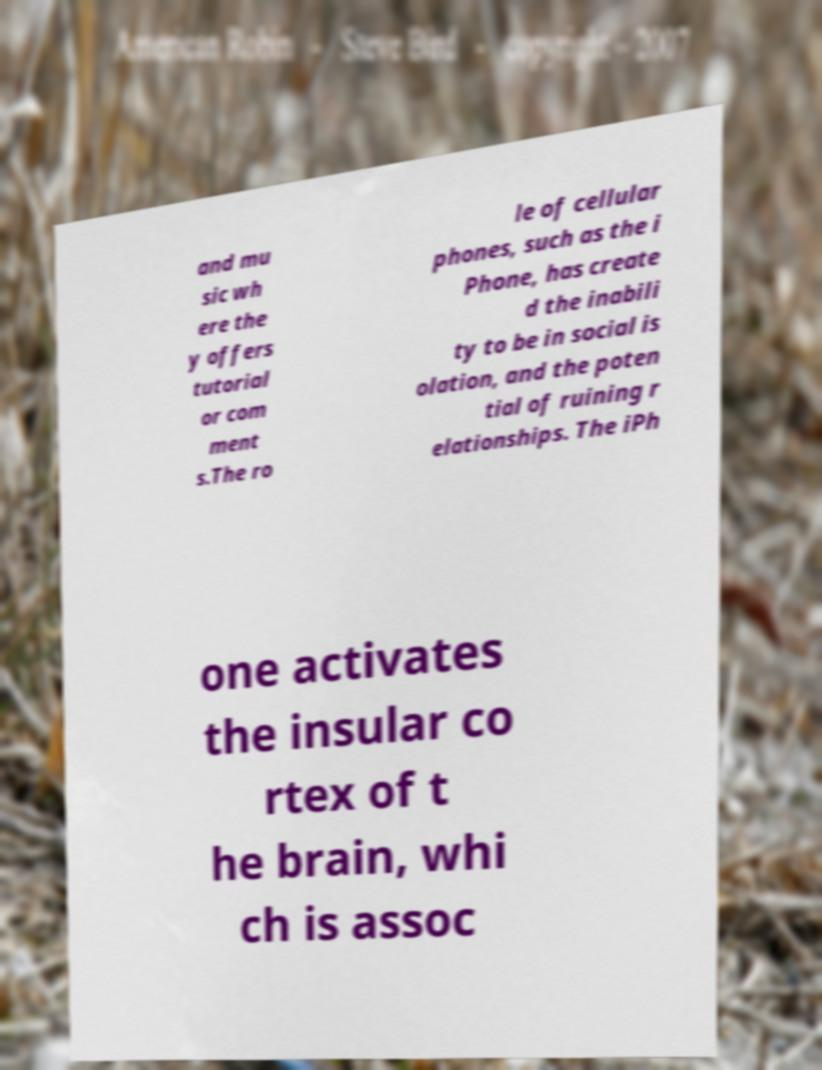Can you read and provide the text displayed in the image?This photo seems to have some interesting text. Can you extract and type it out for me? and mu sic wh ere the y offers tutorial or com ment s.The ro le of cellular phones, such as the i Phone, has create d the inabili ty to be in social is olation, and the poten tial of ruining r elationships. The iPh one activates the insular co rtex of t he brain, whi ch is assoc 